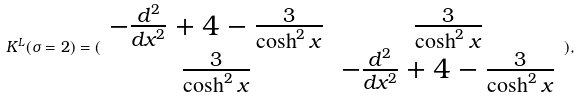<formula> <loc_0><loc_0><loc_500><loc_500>K ^ { L } ( \sigma = 2 ) = ( \begin{array} { c c } - \frac { d ^ { 2 } } { d x ^ { 2 } } + 4 - \frac { 3 } { \cosh ^ { 2 } x } & \frac { 3 } { \cosh ^ { 2 } x } \\ \frac { 3 } { \cosh ^ { 2 } x } & - \frac { d ^ { 2 } } { d x ^ { 2 } } + 4 - \frac { 3 } { \cosh ^ { 2 } x } \end{array} ) ,</formula> 